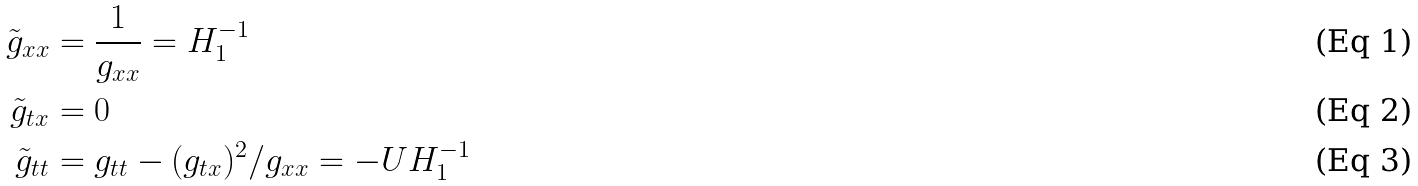<formula> <loc_0><loc_0><loc_500><loc_500>\tilde { g } _ { x x } & = \frac { 1 } { g _ { x x } } = H _ { 1 } ^ { - 1 } \\ \tilde { g } _ { t x } & = 0 \\ \tilde { g } _ { t t } & = g _ { t t } - ( g _ { t x } ) ^ { 2 } / g _ { x x } = - U H _ { 1 } ^ { - 1 }</formula> 